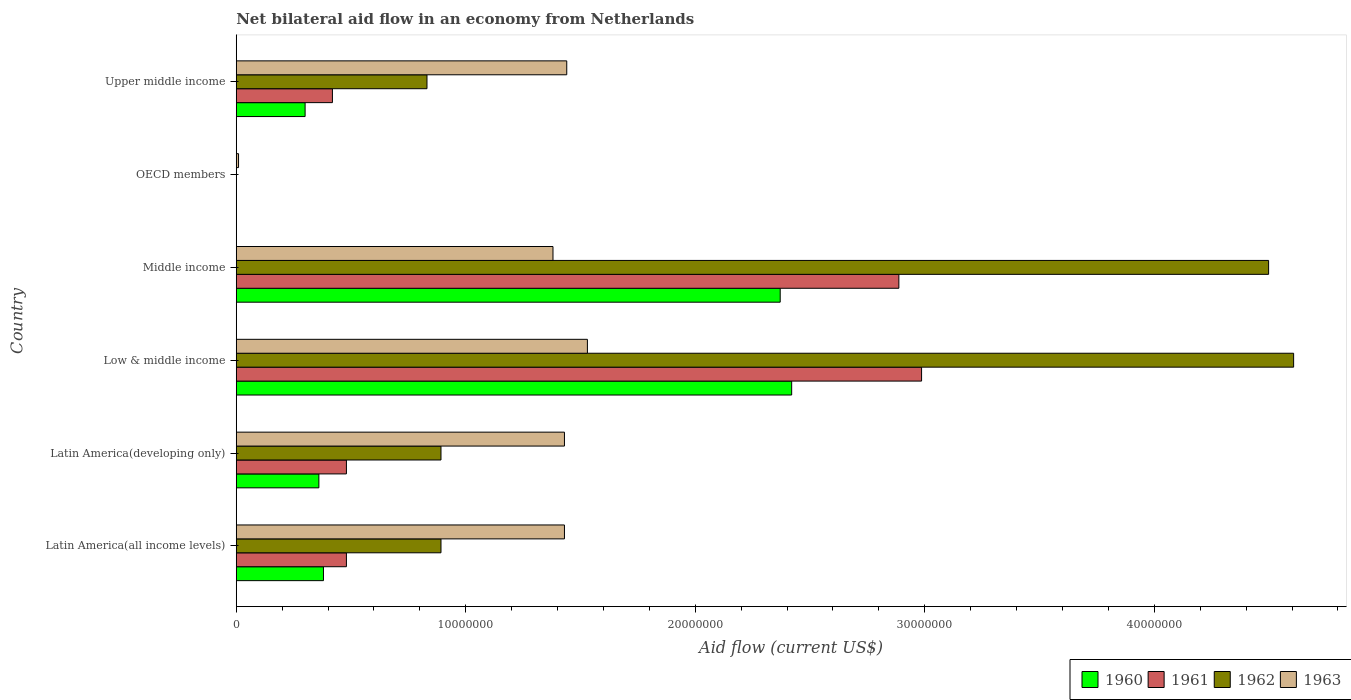How many bars are there on the 6th tick from the top?
Keep it short and to the point. 4. How many bars are there on the 2nd tick from the bottom?
Your answer should be very brief. 4. What is the label of the 5th group of bars from the top?
Ensure brevity in your answer.  Latin America(developing only). What is the net bilateral aid flow in 1960 in Latin America(all income levels)?
Offer a very short reply. 3.80e+06. Across all countries, what is the maximum net bilateral aid flow in 1962?
Offer a very short reply. 4.61e+07. Across all countries, what is the minimum net bilateral aid flow in 1961?
Your answer should be compact. 0. In which country was the net bilateral aid flow in 1962 maximum?
Make the answer very short. Low & middle income. What is the total net bilateral aid flow in 1960 in the graph?
Make the answer very short. 5.83e+07. What is the difference between the net bilateral aid flow in 1963 in Latin America(developing only) and that in OECD members?
Make the answer very short. 1.42e+07. What is the difference between the net bilateral aid flow in 1962 in Latin America(developing only) and the net bilateral aid flow in 1963 in Low & middle income?
Make the answer very short. -6.38e+06. What is the average net bilateral aid flow in 1961 per country?
Ensure brevity in your answer.  1.21e+07. What is the difference between the net bilateral aid flow in 1963 and net bilateral aid flow in 1960 in Middle income?
Your answer should be compact. -9.90e+06. In how many countries, is the net bilateral aid flow in 1960 greater than 46000000 US$?
Keep it short and to the point. 0. What is the ratio of the net bilateral aid flow in 1961 in Low & middle income to that in Upper middle income?
Your answer should be compact. 7.13. Is the net bilateral aid flow in 1962 in Middle income less than that in Upper middle income?
Provide a short and direct response. No. Is the difference between the net bilateral aid flow in 1963 in Low & middle income and Middle income greater than the difference between the net bilateral aid flow in 1960 in Low & middle income and Middle income?
Offer a terse response. Yes. What is the difference between the highest and the second highest net bilateral aid flow in 1960?
Keep it short and to the point. 5.00e+05. What is the difference between the highest and the lowest net bilateral aid flow in 1962?
Ensure brevity in your answer.  4.61e+07. In how many countries, is the net bilateral aid flow in 1963 greater than the average net bilateral aid flow in 1963 taken over all countries?
Offer a very short reply. 5. How many countries are there in the graph?
Your answer should be compact. 6. What is the difference between two consecutive major ticks on the X-axis?
Ensure brevity in your answer.  1.00e+07. Does the graph contain any zero values?
Provide a short and direct response. Yes. What is the title of the graph?
Offer a very short reply. Net bilateral aid flow in an economy from Netherlands. Does "2008" appear as one of the legend labels in the graph?
Your answer should be compact. No. What is the Aid flow (current US$) of 1960 in Latin America(all income levels)?
Your response must be concise. 3.80e+06. What is the Aid flow (current US$) in 1961 in Latin America(all income levels)?
Give a very brief answer. 4.80e+06. What is the Aid flow (current US$) of 1962 in Latin America(all income levels)?
Ensure brevity in your answer.  8.92e+06. What is the Aid flow (current US$) in 1963 in Latin America(all income levels)?
Keep it short and to the point. 1.43e+07. What is the Aid flow (current US$) in 1960 in Latin America(developing only)?
Keep it short and to the point. 3.60e+06. What is the Aid flow (current US$) of 1961 in Latin America(developing only)?
Ensure brevity in your answer.  4.80e+06. What is the Aid flow (current US$) of 1962 in Latin America(developing only)?
Your answer should be very brief. 8.92e+06. What is the Aid flow (current US$) of 1963 in Latin America(developing only)?
Keep it short and to the point. 1.43e+07. What is the Aid flow (current US$) in 1960 in Low & middle income?
Provide a succinct answer. 2.42e+07. What is the Aid flow (current US$) of 1961 in Low & middle income?
Offer a very short reply. 2.99e+07. What is the Aid flow (current US$) of 1962 in Low & middle income?
Give a very brief answer. 4.61e+07. What is the Aid flow (current US$) in 1963 in Low & middle income?
Provide a succinct answer. 1.53e+07. What is the Aid flow (current US$) of 1960 in Middle income?
Your response must be concise. 2.37e+07. What is the Aid flow (current US$) in 1961 in Middle income?
Provide a short and direct response. 2.89e+07. What is the Aid flow (current US$) in 1962 in Middle income?
Provide a succinct answer. 4.50e+07. What is the Aid flow (current US$) of 1963 in Middle income?
Your answer should be compact. 1.38e+07. What is the Aid flow (current US$) in 1961 in OECD members?
Your answer should be compact. 0. What is the Aid flow (current US$) in 1962 in OECD members?
Provide a succinct answer. 0. What is the Aid flow (current US$) of 1961 in Upper middle income?
Keep it short and to the point. 4.19e+06. What is the Aid flow (current US$) of 1962 in Upper middle income?
Keep it short and to the point. 8.31e+06. What is the Aid flow (current US$) in 1963 in Upper middle income?
Keep it short and to the point. 1.44e+07. Across all countries, what is the maximum Aid flow (current US$) in 1960?
Ensure brevity in your answer.  2.42e+07. Across all countries, what is the maximum Aid flow (current US$) of 1961?
Your response must be concise. 2.99e+07. Across all countries, what is the maximum Aid flow (current US$) of 1962?
Your answer should be very brief. 4.61e+07. Across all countries, what is the maximum Aid flow (current US$) in 1963?
Your answer should be compact. 1.53e+07. Across all countries, what is the minimum Aid flow (current US$) of 1960?
Offer a very short reply. 0. What is the total Aid flow (current US$) in 1960 in the graph?
Make the answer very short. 5.83e+07. What is the total Aid flow (current US$) of 1961 in the graph?
Your response must be concise. 7.25e+07. What is the total Aid flow (current US$) in 1962 in the graph?
Give a very brief answer. 1.17e+08. What is the total Aid flow (current US$) of 1963 in the graph?
Offer a terse response. 7.22e+07. What is the difference between the Aid flow (current US$) in 1961 in Latin America(all income levels) and that in Latin America(developing only)?
Provide a short and direct response. 0. What is the difference between the Aid flow (current US$) in 1963 in Latin America(all income levels) and that in Latin America(developing only)?
Your answer should be compact. 0. What is the difference between the Aid flow (current US$) in 1960 in Latin America(all income levels) and that in Low & middle income?
Your answer should be compact. -2.04e+07. What is the difference between the Aid flow (current US$) in 1961 in Latin America(all income levels) and that in Low & middle income?
Offer a terse response. -2.51e+07. What is the difference between the Aid flow (current US$) in 1962 in Latin America(all income levels) and that in Low & middle income?
Keep it short and to the point. -3.72e+07. What is the difference between the Aid flow (current US$) in 1963 in Latin America(all income levels) and that in Low & middle income?
Offer a very short reply. -1.00e+06. What is the difference between the Aid flow (current US$) of 1960 in Latin America(all income levels) and that in Middle income?
Keep it short and to the point. -1.99e+07. What is the difference between the Aid flow (current US$) of 1961 in Latin America(all income levels) and that in Middle income?
Your answer should be very brief. -2.41e+07. What is the difference between the Aid flow (current US$) in 1962 in Latin America(all income levels) and that in Middle income?
Ensure brevity in your answer.  -3.61e+07. What is the difference between the Aid flow (current US$) of 1963 in Latin America(all income levels) and that in Middle income?
Your response must be concise. 5.00e+05. What is the difference between the Aid flow (current US$) in 1963 in Latin America(all income levels) and that in OECD members?
Offer a terse response. 1.42e+07. What is the difference between the Aid flow (current US$) in 1962 in Latin America(all income levels) and that in Upper middle income?
Keep it short and to the point. 6.10e+05. What is the difference between the Aid flow (current US$) of 1963 in Latin America(all income levels) and that in Upper middle income?
Offer a terse response. -1.00e+05. What is the difference between the Aid flow (current US$) of 1960 in Latin America(developing only) and that in Low & middle income?
Your response must be concise. -2.06e+07. What is the difference between the Aid flow (current US$) in 1961 in Latin America(developing only) and that in Low & middle income?
Give a very brief answer. -2.51e+07. What is the difference between the Aid flow (current US$) in 1962 in Latin America(developing only) and that in Low & middle income?
Give a very brief answer. -3.72e+07. What is the difference between the Aid flow (current US$) of 1960 in Latin America(developing only) and that in Middle income?
Offer a very short reply. -2.01e+07. What is the difference between the Aid flow (current US$) of 1961 in Latin America(developing only) and that in Middle income?
Provide a short and direct response. -2.41e+07. What is the difference between the Aid flow (current US$) of 1962 in Latin America(developing only) and that in Middle income?
Your response must be concise. -3.61e+07. What is the difference between the Aid flow (current US$) in 1963 in Latin America(developing only) and that in OECD members?
Ensure brevity in your answer.  1.42e+07. What is the difference between the Aid flow (current US$) of 1960 in Latin America(developing only) and that in Upper middle income?
Give a very brief answer. 6.00e+05. What is the difference between the Aid flow (current US$) in 1963 in Latin America(developing only) and that in Upper middle income?
Your response must be concise. -1.00e+05. What is the difference between the Aid flow (current US$) in 1960 in Low & middle income and that in Middle income?
Your answer should be very brief. 5.00e+05. What is the difference between the Aid flow (current US$) in 1961 in Low & middle income and that in Middle income?
Give a very brief answer. 9.90e+05. What is the difference between the Aid flow (current US$) in 1962 in Low & middle income and that in Middle income?
Your answer should be very brief. 1.09e+06. What is the difference between the Aid flow (current US$) of 1963 in Low & middle income and that in Middle income?
Your response must be concise. 1.50e+06. What is the difference between the Aid flow (current US$) of 1963 in Low & middle income and that in OECD members?
Ensure brevity in your answer.  1.52e+07. What is the difference between the Aid flow (current US$) in 1960 in Low & middle income and that in Upper middle income?
Provide a succinct answer. 2.12e+07. What is the difference between the Aid flow (current US$) of 1961 in Low & middle income and that in Upper middle income?
Provide a short and direct response. 2.57e+07. What is the difference between the Aid flow (current US$) in 1962 in Low & middle income and that in Upper middle income?
Make the answer very short. 3.78e+07. What is the difference between the Aid flow (current US$) of 1963 in Middle income and that in OECD members?
Offer a terse response. 1.37e+07. What is the difference between the Aid flow (current US$) in 1960 in Middle income and that in Upper middle income?
Offer a very short reply. 2.07e+07. What is the difference between the Aid flow (current US$) in 1961 in Middle income and that in Upper middle income?
Make the answer very short. 2.47e+07. What is the difference between the Aid flow (current US$) in 1962 in Middle income and that in Upper middle income?
Offer a very short reply. 3.67e+07. What is the difference between the Aid flow (current US$) of 1963 in Middle income and that in Upper middle income?
Provide a succinct answer. -6.00e+05. What is the difference between the Aid flow (current US$) in 1963 in OECD members and that in Upper middle income?
Your response must be concise. -1.43e+07. What is the difference between the Aid flow (current US$) of 1960 in Latin America(all income levels) and the Aid flow (current US$) of 1961 in Latin America(developing only)?
Offer a terse response. -1.00e+06. What is the difference between the Aid flow (current US$) in 1960 in Latin America(all income levels) and the Aid flow (current US$) in 1962 in Latin America(developing only)?
Provide a short and direct response. -5.12e+06. What is the difference between the Aid flow (current US$) in 1960 in Latin America(all income levels) and the Aid flow (current US$) in 1963 in Latin America(developing only)?
Your response must be concise. -1.05e+07. What is the difference between the Aid flow (current US$) of 1961 in Latin America(all income levels) and the Aid flow (current US$) of 1962 in Latin America(developing only)?
Your response must be concise. -4.12e+06. What is the difference between the Aid flow (current US$) of 1961 in Latin America(all income levels) and the Aid flow (current US$) of 1963 in Latin America(developing only)?
Offer a terse response. -9.50e+06. What is the difference between the Aid flow (current US$) of 1962 in Latin America(all income levels) and the Aid flow (current US$) of 1963 in Latin America(developing only)?
Give a very brief answer. -5.38e+06. What is the difference between the Aid flow (current US$) of 1960 in Latin America(all income levels) and the Aid flow (current US$) of 1961 in Low & middle income?
Your response must be concise. -2.61e+07. What is the difference between the Aid flow (current US$) of 1960 in Latin America(all income levels) and the Aid flow (current US$) of 1962 in Low & middle income?
Make the answer very short. -4.23e+07. What is the difference between the Aid flow (current US$) in 1960 in Latin America(all income levels) and the Aid flow (current US$) in 1963 in Low & middle income?
Offer a very short reply. -1.15e+07. What is the difference between the Aid flow (current US$) in 1961 in Latin America(all income levels) and the Aid flow (current US$) in 1962 in Low & middle income?
Offer a very short reply. -4.13e+07. What is the difference between the Aid flow (current US$) in 1961 in Latin America(all income levels) and the Aid flow (current US$) in 1963 in Low & middle income?
Provide a succinct answer. -1.05e+07. What is the difference between the Aid flow (current US$) of 1962 in Latin America(all income levels) and the Aid flow (current US$) of 1963 in Low & middle income?
Ensure brevity in your answer.  -6.38e+06. What is the difference between the Aid flow (current US$) of 1960 in Latin America(all income levels) and the Aid flow (current US$) of 1961 in Middle income?
Your answer should be compact. -2.51e+07. What is the difference between the Aid flow (current US$) of 1960 in Latin America(all income levels) and the Aid flow (current US$) of 1962 in Middle income?
Provide a short and direct response. -4.12e+07. What is the difference between the Aid flow (current US$) in 1960 in Latin America(all income levels) and the Aid flow (current US$) in 1963 in Middle income?
Provide a short and direct response. -1.00e+07. What is the difference between the Aid flow (current US$) in 1961 in Latin America(all income levels) and the Aid flow (current US$) in 1962 in Middle income?
Offer a terse response. -4.02e+07. What is the difference between the Aid flow (current US$) of 1961 in Latin America(all income levels) and the Aid flow (current US$) of 1963 in Middle income?
Give a very brief answer. -9.00e+06. What is the difference between the Aid flow (current US$) of 1962 in Latin America(all income levels) and the Aid flow (current US$) of 1963 in Middle income?
Provide a short and direct response. -4.88e+06. What is the difference between the Aid flow (current US$) in 1960 in Latin America(all income levels) and the Aid flow (current US$) in 1963 in OECD members?
Keep it short and to the point. 3.70e+06. What is the difference between the Aid flow (current US$) in 1961 in Latin America(all income levels) and the Aid flow (current US$) in 1963 in OECD members?
Provide a succinct answer. 4.70e+06. What is the difference between the Aid flow (current US$) in 1962 in Latin America(all income levels) and the Aid flow (current US$) in 1963 in OECD members?
Your response must be concise. 8.82e+06. What is the difference between the Aid flow (current US$) in 1960 in Latin America(all income levels) and the Aid flow (current US$) in 1961 in Upper middle income?
Give a very brief answer. -3.90e+05. What is the difference between the Aid flow (current US$) in 1960 in Latin America(all income levels) and the Aid flow (current US$) in 1962 in Upper middle income?
Ensure brevity in your answer.  -4.51e+06. What is the difference between the Aid flow (current US$) in 1960 in Latin America(all income levels) and the Aid flow (current US$) in 1963 in Upper middle income?
Provide a succinct answer. -1.06e+07. What is the difference between the Aid flow (current US$) of 1961 in Latin America(all income levels) and the Aid flow (current US$) of 1962 in Upper middle income?
Your answer should be compact. -3.51e+06. What is the difference between the Aid flow (current US$) in 1961 in Latin America(all income levels) and the Aid flow (current US$) in 1963 in Upper middle income?
Offer a very short reply. -9.60e+06. What is the difference between the Aid flow (current US$) of 1962 in Latin America(all income levels) and the Aid flow (current US$) of 1963 in Upper middle income?
Give a very brief answer. -5.48e+06. What is the difference between the Aid flow (current US$) of 1960 in Latin America(developing only) and the Aid flow (current US$) of 1961 in Low & middle income?
Offer a terse response. -2.63e+07. What is the difference between the Aid flow (current US$) of 1960 in Latin America(developing only) and the Aid flow (current US$) of 1962 in Low & middle income?
Your answer should be very brief. -4.25e+07. What is the difference between the Aid flow (current US$) of 1960 in Latin America(developing only) and the Aid flow (current US$) of 1963 in Low & middle income?
Your response must be concise. -1.17e+07. What is the difference between the Aid flow (current US$) in 1961 in Latin America(developing only) and the Aid flow (current US$) in 1962 in Low & middle income?
Your answer should be compact. -4.13e+07. What is the difference between the Aid flow (current US$) in 1961 in Latin America(developing only) and the Aid flow (current US$) in 1963 in Low & middle income?
Your answer should be very brief. -1.05e+07. What is the difference between the Aid flow (current US$) in 1962 in Latin America(developing only) and the Aid flow (current US$) in 1963 in Low & middle income?
Provide a succinct answer. -6.38e+06. What is the difference between the Aid flow (current US$) in 1960 in Latin America(developing only) and the Aid flow (current US$) in 1961 in Middle income?
Offer a terse response. -2.53e+07. What is the difference between the Aid flow (current US$) in 1960 in Latin America(developing only) and the Aid flow (current US$) in 1962 in Middle income?
Your response must be concise. -4.14e+07. What is the difference between the Aid flow (current US$) of 1960 in Latin America(developing only) and the Aid flow (current US$) of 1963 in Middle income?
Provide a succinct answer. -1.02e+07. What is the difference between the Aid flow (current US$) in 1961 in Latin America(developing only) and the Aid flow (current US$) in 1962 in Middle income?
Provide a short and direct response. -4.02e+07. What is the difference between the Aid flow (current US$) of 1961 in Latin America(developing only) and the Aid flow (current US$) of 1963 in Middle income?
Offer a very short reply. -9.00e+06. What is the difference between the Aid flow (current US$) in 1962 in Latin America(developing only) and the Aid flow (current US$) in 1963 in Middle income?
Offer a terse response. -4.88e+06. What is the difference between the Aid flow (current US$) of 1960 in Latin America(developing only) and the Aid flow (current US$) of 1963 in OECD members?
Give a very brief answer. 3.50e+06. What is the difference between the Aid flow (current US$) in 1961 in Latin America(developing only) and the Aid flow (current US$) in 1963 in OECD members?
Offer a very short reply. 4.70e+06. What is the difference between the Aid flow (current US$) of 1962 in Latin America(developing only) and the Aid flow (current US$) of 1963 in OECD members?
Your response must be concise. 8.82e+06. What is the difference between the Aid flow (current US$) in 1960 in Latin America(developing only) and the Aid flow (current US$) in 1961 in Upper middle income?
Provide a short and direct response. -5.90e+05. What is the difference between the Aid flow (current US$) of 1960 in Latin America(developing only) and the Aid flow (current US$) of 1962 in Upper middle income?
Provide a succinct answer. -4.71e+06. What is the difference between the Aid flow (current US$) of 1960 in Latin America(developing only) and the Aid flow (current US$) of 1963 in Upper middle income?
Keep it short and to the point. -1.08e+07. What is the difference between the Aid flow (current US$) of 1961 in Latin America(developing only) and the Aid flow (current US$) of 1962 in Upper middle income?
Give a very brief answer. -3.51e+06. What is the difference between the Aid flow (current US$) in 1961 in Latin America(developing only) and the Aid flow (current US$) in 1963 in Upper middle income?
Your answer should be very brief. -9.60e+06. What is the difference between the Aid flow (current US$) of 1962 in Latin America(developing only) and the Aid flow (current US$) of 1963 in Upper middle income?
Ensure brevity in your answer.  -5.48e+06. What is the difference between the Aid flow (current US$) in 1960 in Low & middle income and the Aid flow (current US$) in 1961 in Middle income?
Provide a short and direct response. -4.67e+06. What is the difference between the Aid flow (current US$) in 1960 in Low & middle income and the Aid flow (current US$) in 1962 in Middle income?
Provide a succinct answer. -2.08e+07. What is the difference between the Aid flow (current US$) of 1960 in Low & middle income and the Aid flow (current US$) of 1963 in Middle income?
Offer a very short reply. 1.04e+07. What is the difference between the Aid flow (current US$) in 1961 in Low & middle income and the Aid flow (current US$) in 1962 in Middle income?
Make the answer very short. -1.51e+07. What is the difference between the Aid flow (current US$) in 1961 in Low & middle income and the Aid flow (current US$) in 1963 in Middle income?
Keep it short and to the point. 1.61e+07. What is the difference between the Aid flow (current US$) in 1962 in Low & middle income and the Aid flow (current US$) in 1963 in Middle income?
Your answer should be compact. 3.23e+07. What is the difference between the Aid flow (current US$) of 1960 in Low & middle income and the Aid flow (current US$) of 1963 in OECD members?
Your answer should be compact. 2.41e+07. What is the difference between the Aid flow (current US$) of 1961 in Low & middle income and the Aid flow (current US$) of 1963 in OECD members?
Provide a succinct answer. 2.98e+07. What is the difference between the Aid flow (current US$) of 1962 in Low & middle income and the Aid flow (current US$) of 1963 in OECD members?
Ensure brevity in your answer.  4.60e+07. What is the difference between the Aid flow (current US$) in 1960 in Low & middle income and the Aid flow (current US$) in 1961 in Upper middle income?
Keep it short and to the point. 2.00e+07. What is the difference between the Aid flow (current US$) in 1960 in Low & middle income and the Aid flow (current US$) in 1962 in Upper middle income?
Your response must be concise. 1.59e+07. What is the difference between the Aid flow (current US$) of 1960 in Low & middle income and the Aid flow (current US$) of 1963 in Upper middle income?
Give a very brief answer. 9.80e+06. What is the difference between the Aid flow (current US$) in 1961 in Low & middle income and the Aid flow (current US$) in 1962 in Upper middle income?
Your answer should be compact. 2.16e+07. What is the difference between the Aid flow (current US$) of 1961 in Low & middle income and the Aid flow (current US$) of 1963 in Upper middle income?
Keep it short and to the point. 1.55e+07. What is the difference between the Aid flow (current US$) in 1962 in Low & middle income and the Aid flow (current US$) in 1963 in Upper middle income?
Give a very brief answer. 3.17e+07. What is the difference between the Aid flow (current US$) of 1960 in Middle income and the Aid flow (current US$) of 1963 in OECD members?
Your answer should be compact. 2.36e+07. What is the difference between the Aid flow (current US$) in 1961 in Middle income and the Aid flow (current US$) in 1963 in OECD members?
Provide a short and direct response. 2.88e+07. What is the difference between the Aid flow (current US$) of 1962 in Middle income and the Aid flow (current US$) of 1963 in OECD members?
Keep it short and to the point. 4.49e+07. What is the difference between the Aid flow (current US$) in 1960 in Middle income and the Aid flow (current US$) in 1961 in Upper middle income?
Your response must be concise. 1.95e+07. What is the difference between the Aid flow (current US$) of 1960 in Middle income and the Aid flow (current US$) of 1962 in Upper middle income?
Provide a short and direct response. 1.54e+07. What is the difference between the Aid flow (current US$) in 1960 in Middle income and the Aid flow (current US$) in 1963 in Upper middle income?
Your answer should be compact. 9.30e+06. What is the difference between the Aid flow (current US$) of 1961 in Middle income and the Aid flow (current US$) of 1962 in Upper middle income?
Offer a very short reply. 2.06e+07. What is the difference between the Aid flow (current US$) of 1961 in Middle income and the Aid flow (current US$) of 1963 in Upper middle income?
Give a very brief answer. 1.45e+07. What is the difference between the Aid flow (current US$) of 1962 in Middle income and the Aid flow (current US$) of 1963 in Upper middle income?
Your response must be concise. 3.06e+07. What is the average Aid flow (current US$) in 1960 per country?
Keep it short and to the point. 9.72e+06. What is the average Aid flow (current US$) of 1961 per country?
Make the answer very short. 1.21e+07. What is the average Aid flow (current US$) in 1962 per country?
Give a very brief answer. 1.95e+07. What is the average Aid flow (current US$) in 1963 per country?
Keep it short and to the point. 1.20e+07. What is the difference between the Aid flow (current US$) of 1960 and Aid flow (current US$) of 1961 in Latin America(all income levels)?
Offer a terse response. -1.00e+06. What is the difference between the Aid flow (current US$) of 1960 and Aid flow (current US$) of 1962 in Latin America(all income levels)?
Offer a terse response. -5.12e+06. What is the difference between the Aid flow (current US$) in 1960 and Aid flow (current US$) in 1963 in Latin America(all income levels)?
Ensure brevity in your answer.  -1.05e+07. What is the difference between the Aid flow (current US$) in 1961 and Aid flow (current US$) in 1962 in Latin America(all income levels)?
Your answer should be very brief. -4.12e+06. What is the difference between the Aid flow (current US$) of 1961 and Aid flow (current US$) of 1963 in Latin America(all income levels)?
Give a very brief answer. -9.50e+06. What is the difference between the Aid flow (current US$) of 1962 and Aid flow (current US$) of 1963 in Latin America(all income levels)?
Offer a very short reply. -5.38e+06. What is the difference between the Aid flow (current US$) of 1960 and Aid flow (current US$) of 1961 in Latin America(developing only)?
Ensure brevity in your answer.  -1.20e+06. What is the difference between the Aid flow (current US$) in 1960 and Aid flow (current US$) in 1962 in Latin America(developing only)?
Your answer should be compact. -5.32e+06. What is the difference between the Aid flow (current US$) in 1960 and Aid flow (current US$) in 1963 in Latin America(developing only)?
Make the answer very short. -1.07e+07. What is the difference between the Aid flow (current US$) of 1961 and Aid flow (current US$) of 1962 in Latin America(developing only)?
Keep it short and to the point. -4.12e+06. What is the difference between the Aid flow (current US$) in 1961 and Aid flow (current US$) in 1963 in Latin America(developing only)?
Offer a terse response. -9.50e+06. What is the difference between the Aid flow (current US$) of 1962 and Aid flow (current US$) of 1963 in Latin America(developing only)?
Provide a short and direct response. -5.38e+06. What is the difference between the Aid flow (current US$) of 1960 and Aid flow (current US$) of 1961 in Low & middle income?
Make the answer very short. -5.66e+06. What is the difference between the Aid flow (current US$) in 1960 and Aid flow (current US$) in 1962 in Low & middle income?
Make the answer very short. -2.19e+07. What is the difference between the Aid flow (current US$) of 1960 and Aid flow (current US$) of 1963 in Low & middle income?
Offer a terse response. 8.90e+06. What is the difference between the Aid flow (current US$) in 1961 and Aid flow (current US$) in 1962 in Low & middle income?
Keep it short and to the point. -1.62e+07. What is the difference between the Aid flow (current US$) of 1961 and Aid flow (current US$) of 1963 in Low & middle income?
Provide a short and direct response. 1.46e+07. What is the difference between the Aid flow (current US$) of 1962 and Aid flow (current US$) of 1963 in Low & middle income?
Your answer should be compact. 3.08e+07. What is the difference between the Aid flow (current US$) in 1960 and Aid flow (current US$) in 1961 in Middle income?
Provide a succinct answer. -5.17e+06. What is the difference between the Aid flow (current US$) in 1960 and Aid flow (current US$) in 1962 in Middle income?
Offer a terse response. -2.13e+07. What is the difference between the Aid flow (current US$) of 1960 and Aid flow (current US$) of 1963 in Middle income?
Make the answer very short. 9.90e+06. What is the difference between the Aid flow (current US$) of 1961 and Aid flow (current US$) of 1962 in Middle income?
Provide a succinct answer. -1.61e+07. What is the difference between the Aid flow (current US$) of 1961 and Aid flow (current US$) of 1963 in Middle income?
Offer a terse response. 1.51e+07. What is the difference between the Aid flow (current US$) in 1962 and Aid flow (current US$) in 1963 in Middle income?
Provide a succinct answer. 3.12e+07. What is the difference between the Aid flow (current US$) in 1960 and Aid flow (current US$) in 1961 in Upper middle income?
Your answer should be very brief. -1.19e+06. What is the difference between the Aid flow (current US$) in 1960 and Aid flow (current US$) in 1962 in Upper middle income?
Offer a very short reply. -5.31e+06. What is the difference between the Aid flow (current US$) of 1960 and Aid flow (current US$) of 1963 in Upper middle income?
Keep it short and to the point. -1.14e+07. What is the difference between the Aid flow (current US$) in 1961 and Aid flow (current US$) in 1962 in Upper middle income?
Your answer should be very brief. -4.12e+06. What is the difference between the Aid flow (current US$) of 1961 and Aid flow (current US$) of 1963 in Upper middle income?
Provide a succinct answer. -1.02e+07. What is the difference between the Aid flow (current US$) of 1962 and Aid flow (current US$) of 1963 in Upper middle income?
Offer a terse response. -6.09e+06. What is the ratio of the Aid flow (current US$) in 1960 in Latin America(all income levels) to that in Latin America(developing only)?
Provide a succinct answer. 1.06. What is the ratio of the Aid flow (current US$) of 1960 in Latin America(all income levels) to that in Low & middle income?
Keep it short and to the point. 0.16. What is the ratio of the Aid flow (current US$) of 1961 in Latin America(all income levels) to that in Low & middle income?
Provide a succinct answer. 0.16. What is the ratio of the Aid flow (current US$) in 1962 in Latin America(all income levels) to that in Low & middle income?
Keep it short and to the point. 0.19. What is the ratio of the Aid flow (current US$) of 1963 in Latin America(all income levels) to that in Low & middle income?
Provide a succinct answer. 0.93. What is the ratio of the Aid flow (current US$) in 1960 in Latin America(all income levels) to that in Middle income?
Your response must be concise. 0.16. What is the ratio of the Aid flow (current US$) in 1961 in Latin America(all income levels) to that in Middle income?
Your answer should be very brief. 0.17. What is the ratio of the Aid flow (current US$) of 1962 in Latin America(all income levels) to that in Middle income?
Offer a very short reply. 0.2. What is the ratio of the Aid flow (current US$) in 1963 in Latin America(all income levels) to that in Middle income?
Offer a terse response. 1.04. What is the ratio of the Aid flow (current US$) of 1963 in Latin America(all income levels) to that in OECD members?
Provide a succinct answer. 143. What is the ratio of the Aid flow (current US$) of 1960 in Latin America(all income levels) to that in Upper middle income?
Offer a very short reply. 1.27. What is the ratio of the Aid flow (current US$) of 1961 in Latin America(all income levels) to that in Upper middle income?
Ensure brevity in your answer.  1.15. What is the ratio of the Aid flow (current US$) in 1962 in Latin America(all income levels) to that in Upper middle income?
Provide a short and direct response. 1.07. What is the ratio of the Aid flow (current US$) of 1960 in Latin America(developing only) to that in Low & middle income?
Make the answer very short. 0.15. What is the ratio of the Aid flow (current US$) of 1961 in Latin America(developing only) to that in Low & middle income?
Give a very brief answer. 0.16. What is the ratio of the Aid flow (current US$) in 1962 in Latin America(developing only) to that in Low & middle income?
Provide a short and direct response. 0.19. What is the ratio of the Aid flow (current US$) in 1963 in Latin America(developing only) to that in Low & middle income?
Provide a succinct answer. 0.93. What is the ratio of the Aid flow (current US$) of 1960 in Latin America(developing only) to that in Middle income?
Offer a very short reply. 0.15. What is the ratio of the Aid flow (current US$) in 1961 in Latin America(developing only) to that in Middle income?
Your response must be concise. 0.17. What is the ratio of the Aid flow (current US$) of 1962 in Latin America(developing only) to that in Middle income?
Make the answer very short. 0.2. What is the ratio of the Aid flow (current US$) of 1963 in Latin America(developing only) to that in Middle income?
Offer a very short reply. 1.04. What is the ratio of the Aid flow (current US$) of 1963 in Latin America(developing only) to that in OECD members?
Make the answer very short. 143. What is the ratio of the Aid flow (current US$) in 1961 in Latin America(developing only) to that in Upper middle income?
Keep it short and to the point. 1.15. What is the ratio of the Aid flow (current US$) of 1962 in Latin America(developing only) to that in Upper middle income?
Your answer should be compact. 1.07. What is the ratio of the Aid flow (current US$) of 1963 in Latin America(developing only) to that in Upper middle income?
Make the answer very short. 0.99. What is the ratio of the Aid flow (current US$) in 1960 in Low & middle income to that in Middle income?
Make the answer very short. 1.02. What is the ratio of the Aid flow (current US$) of 1961 in Low & middle income to that in Middle income?
Make the answer very short. 1.03. What is the ratio of the Aid flow (current US$) in 1962 in Low & middle income to that in Middle income?
Make the answer very short. 1.02. What is the ratio of the Aid flow (current US$) of 1963 in Low & middle income to that in Middle income?
Offer a very short reply. 1.11. What is the ratio of the Aid flow (current US$) of 1963 in Low & middle income to that in OECD members?
Make the answer very short. 153. What is the ratio of the Aid flow (current US$) of 1960 in Low & middle income to that in Upper middle income?
Provide a short and direct response. 8.07. What is the ratio of the Aid flow (current US$) of 1961 in Low & middle income to that in Upper middle income?
Offer a very short reply. 7.13. What is the ratio of the Aid flow (current US$) in 1962 in Low & middle income to that in Upper middle income?
Your answer should be compact. 5.54. What is the ratio of the Aid flow (current US$) of 1963 in Low & middle income to that in Upper middle income?
Provide a short and direct response. 1.06. What is the ratio of the Aid flow (current US$) in 1963 in Middle income to that in OECD members?
Ensure brevity in your answer.  138. What is the ratio of the Aid flow (current US$) of 1960 in Middle income to that in Upper middle income?
Provide a succinct answer. 7.9. What is the ratio of the Aid flow (current US$) of 1961 in Middle income to that in Upper middle income?
Give a very brief answer. 6.89. What is the ratio of the Aid flow (current US$) in 1962 in Middle income to that in Upper middle income?
Offer a terse response. 5.41. What is the ratio of the Aid flow (current US$) in 1963 in OECD members to that in Upper middle income?
Your response must be concise. 0.01. What is the difference between the highest and the second highest Aid flow (current US$) of 1961?
Provide a succinct answer. 9.90e+05. What is the difference between the highest and the second highest Aid flow (current US$) of 1962?
Ensure brevity in your answer.  1.09e+06. What is the difference between the highest and the second highest Aid flow (current US$) of 1963?
Offer a very short reply. 9.00e+05. What is the difference between the highest and the lowest Aid flow (current US$) of 1960?
Provide a succinct answer. 2.42e+07. What is the difference between the highest and the lowest Aid flow (current US$) in 1961?
Provide a succinct answer. 2.99e+07. What is the difference between the highest and the lowest Aid flow (current US$) of 1962?
Your answer should be very brief. 4.61e+07. What is the difference between the highest and the lowest Aid flow (current US$) in 1963?
Offer a terse response. 1.52e+07. 